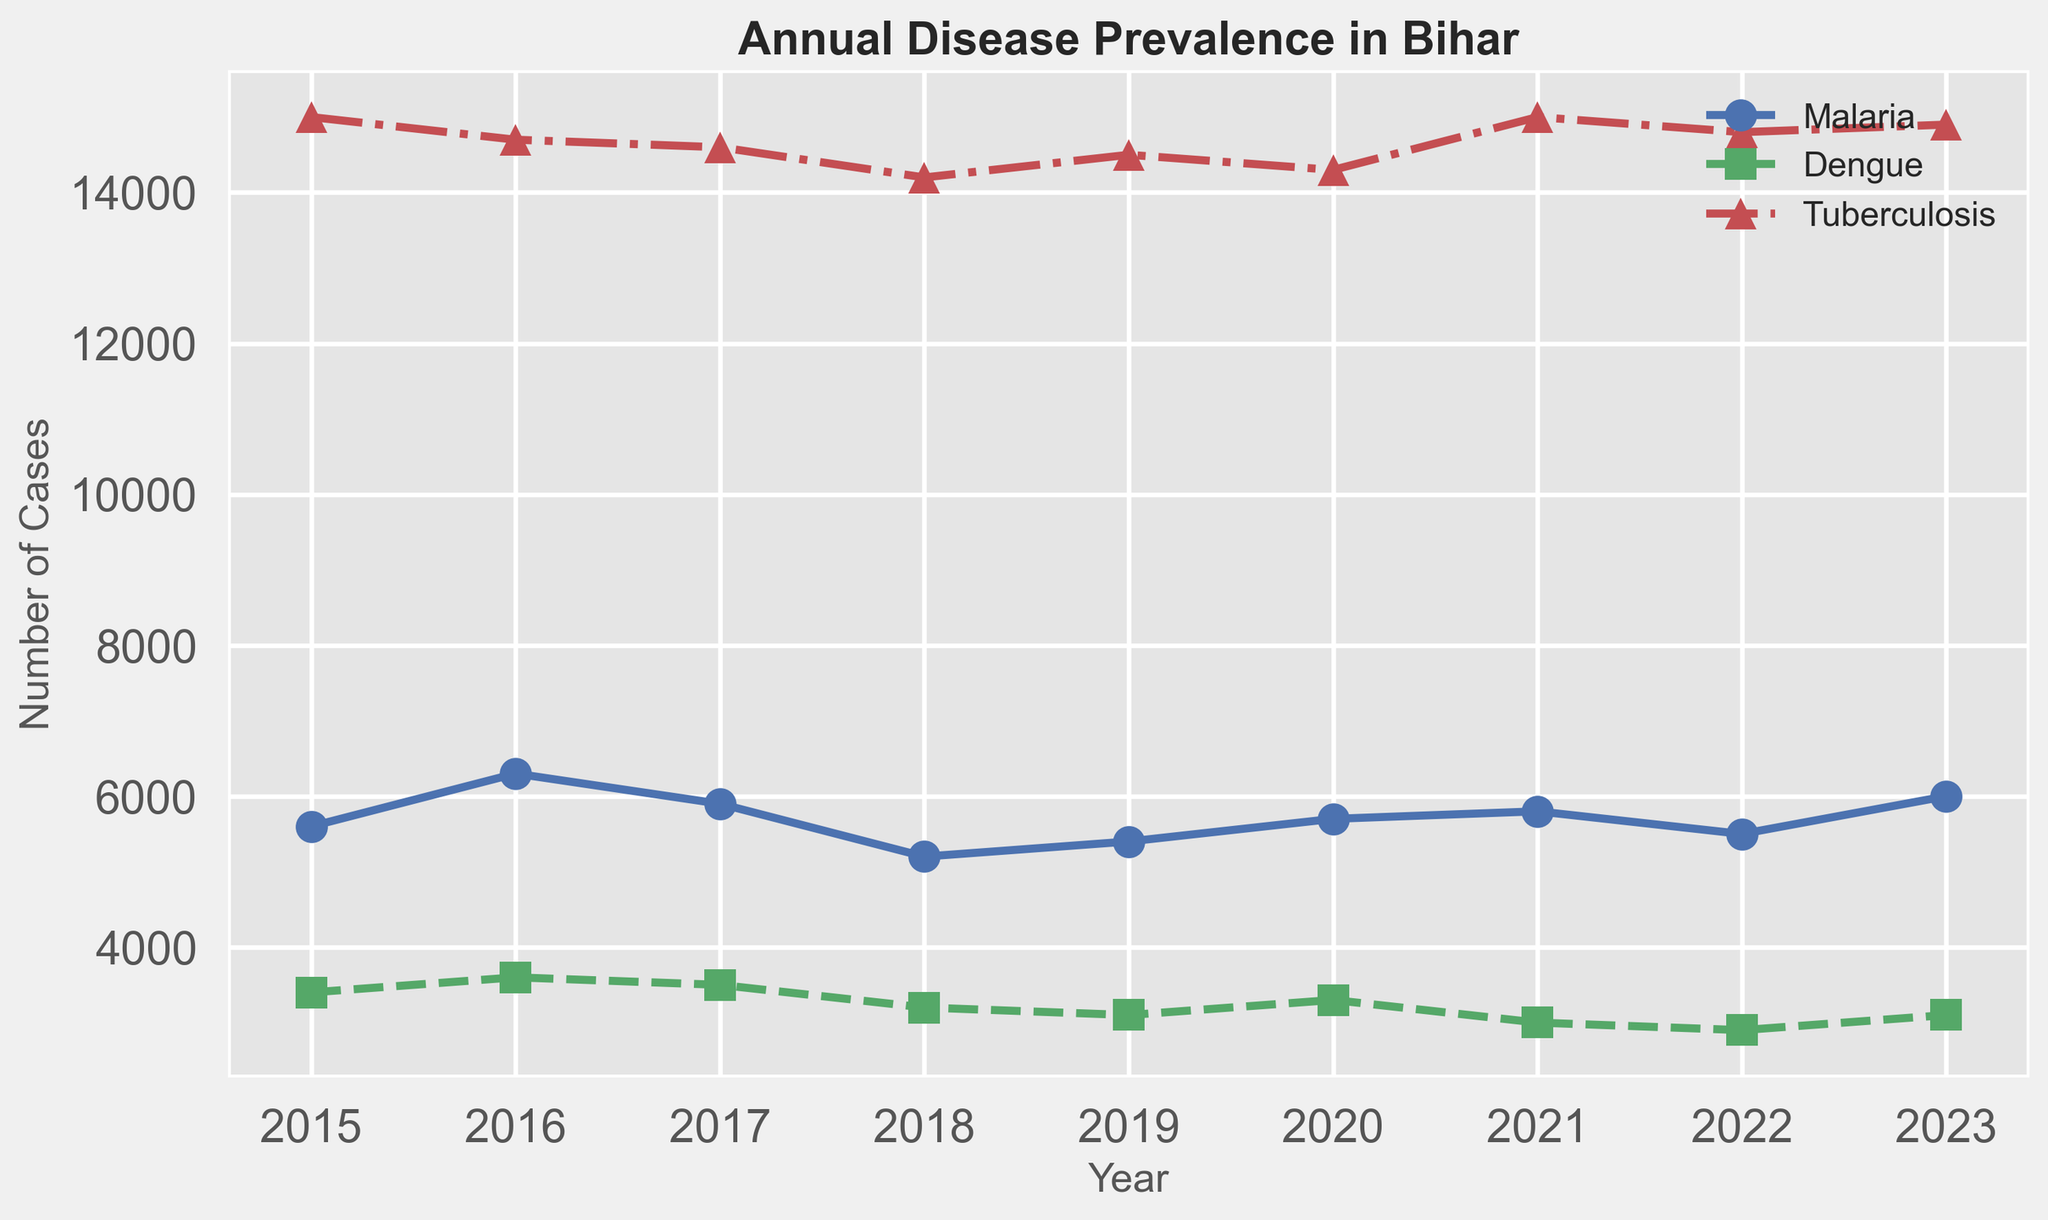What year had the highest prevalence of Malaria? By looking at the line for Malaria (blue line with circle markers), the highest point on the y-axis corresponds to the year 2016.
Answer: 2016 Which disease had the lowest number of cases in 2021? By looking at the 2021 values for each disease, Dengue (green line with square markers) has the lowest value with 3000 cases.
Answer: Dengue From 2015 to 2023, how many years did Tuberculosis have over 14600 cases? The red line with triangle markers representing Tuberculosis is above the 14600 mark in the years 2015, 2016, 2021, 2022, and 2023, which makes a total of 5 years.
Answer: 5 years Compare the trends of Dengue and Tuberculosis from 2018 to 2021. What can be observed? From 2018 to 2021, Dengue cases (green line with square markers) consistently decreased from 3200 to 3000, while Tuberculosis cases (red line with triangle markers) initially slightly rose from 14200 to 14300 and then significantly to 15000 by 2021.
Answer: Dengue decreased, Tuberculosis increased What was the difference in Malaria prevalence between the years 2020 and 2023? The Malaria cases in 2020 were 5700, and in 2023 they were 6000. The difference is calculated as 6000 - 5700 = 300.
Answer: 300 What is the overall trend for Malaria from 2015 to 2023? By visually examining the fluctuation of the blue line with circle markers for Malaria, the trend shows a pattern of ups and downs without a clear upward or downward trajectory over the years.
Answer: No clear trend How did the prevalence of Dengue change from 2015 to 2018? The number of Dengue cases (green line) was 3400 in 2015 and decreased to 3200 by 2018.
Answer: Decreased What can you infer about Tuberculosis cases in 2021 compared to 2020? The red line with triangle markers shows that Tuberculosis cases increased from 14300 in 2020 to 15000 in 2021.
Answer: Increased Which year had the smallest difference between Malaria and Dengue cases? The differences between Malaria (blue line) and Dengue (green line) for each year are calculated as follows: 2015: 2200, 2016: 2700, 2017: 2400, 2018: 2000, 2019: 2300, 2020: 2400, 2021: 2800, 2022: 2600, 2023: 2900. The smallest difference is 2000 in 2018.
Answer: 2018 